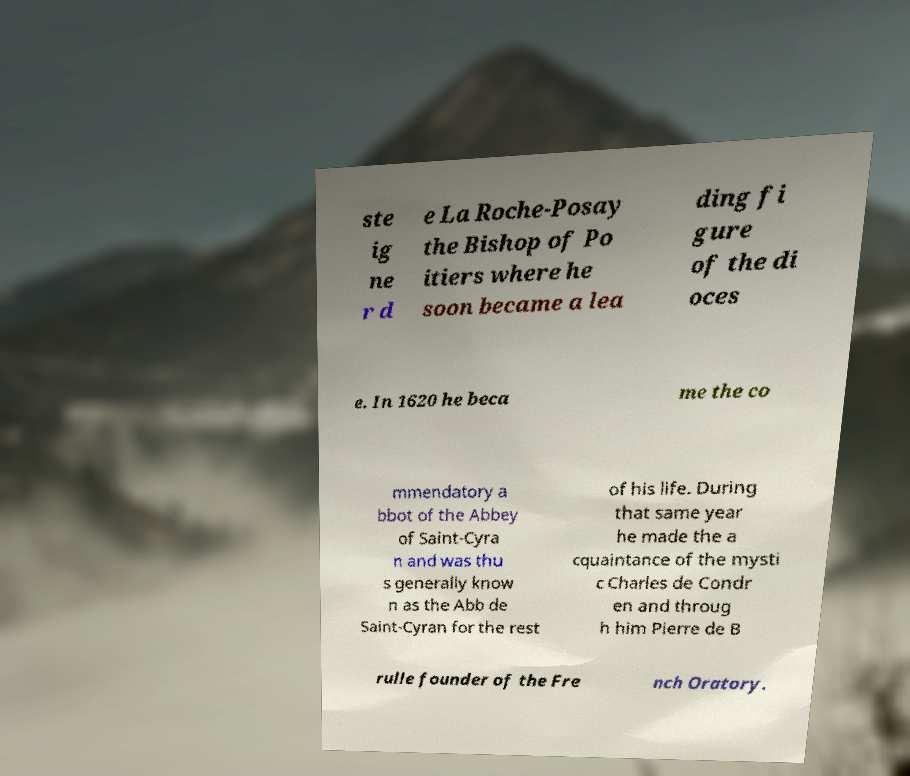What messages or text are displayed in this image? I need them in a readable, typed format. ste ig ne r d e La Roche-Posay the Bishop of Po itiers where he soon became a lea ding fi gure of the di oces e. In 1620 he beca me the co mmendatory a bbot of the Abbey of Saint-Cyra n and was thu s generally know n as the Abb de Saint-Cyran for the rest of his life. During that same year he made the a cquaintance of the mysti c Charles de Condr en and throug h him Pierre de B rulle founder of the Fre nch Oratory. 